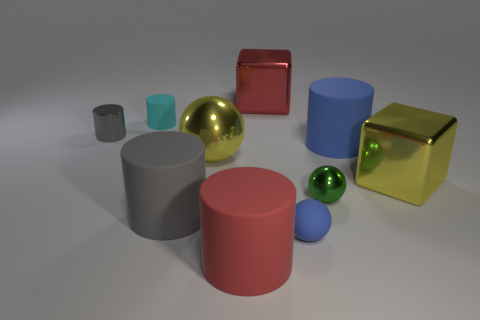Subtract all red cylinders. How many cylinders are left? 4 Subtract all brown cylinders. Subtract all cyan cubes. How many cylinders are left? 5 Subtract all balls. How many objects are left? 7 Subtract 1 cyan cylinders. How many objects are left? 9 Subtract all large balls. Subtract all big red cylinders. How many objects are left? 8 Add 7 green metallic objects. How many green metallic objects are left? 8 Add 5 small yellow rubber objects. How many small yellow rubber objects exist? 5 